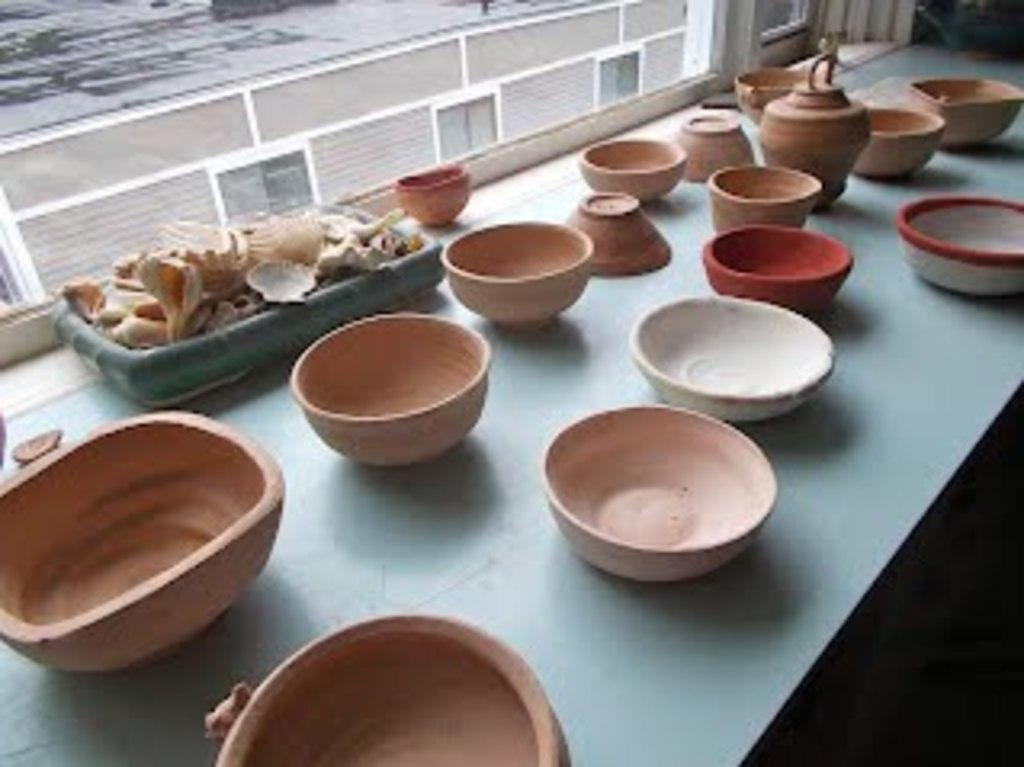What is the main object in the center of the image? There is a table in the center of the image. What items are placed on the table? Clay bowls and a tray of shells are placed on the table. Is there any natural light source visible in the image? Yes, there is a window at the top side of the image. Can you see a plane flying in the image? No, there is no plane visible in the image. What type of steel is used to make the table in the image? The image does not provide information about the material used to make the table, so we cannot determine if steel is used. 